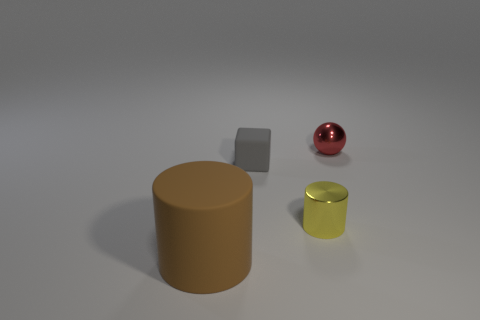Does the cylinder behind the large brown cylinder have the same size as the matte object that is behind the big brown cylinder?
Provide a succinct answer. Yes. Is the number of shiny objects that are on the left side of the yellow cylinder greater than the number of small gray things that are in front of the brown rubber object?
Provide a short and direct response. No. Is there another big blue thing that has the same material as the big object?
Your response must be concise. No. Is the color of the large object the same as the cube?
Make the answer very short. No. The thing that is both in front of the tiny block and behind the large brown rubber thing is made of what material?
Keep it short and to the point. Metal. What is the color of the tiny rubber cube?
Give a very brief answer. Gray. How many big matte things are the same shape as the small yellow thing?
Your answer should be very brief. 1. Is the material of the small thing that is left of the yellow object the same as the tiny object that is on the right side of the tiny shiny cylinder?
Offer a terse response. No. There is a metallic object on the right side of the tiny metallic thing that is left of the tiny red metallic ball; what size is it?
Offer a terse response. Small. Is there any other thing that is the same size as the gray rubber object?
Give a very brief answer. Yes. 